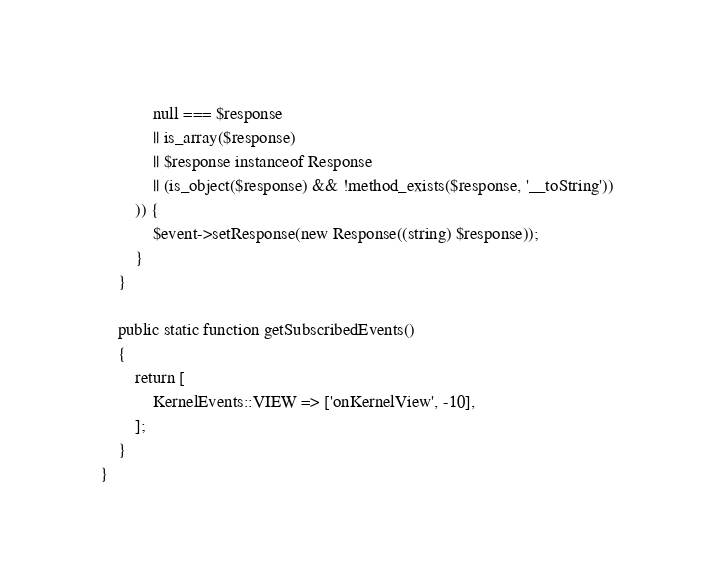Convert code to text. <code><loc_0><loc_0><loc_500><loc_500><_PHP_>            null === $response
            || is_array($response)
            || $response instanceof Response
            || (is_object($response) && !method_exists($response, '__toString'))
        )) {
            $event->setResponse(new Response((string) $response));
        }
    }

    public static function getSubscribedEvents()
    {
        return [
            KernelEvents::VIEW => ['onKernelView', -10],
        ];
    }
}
</code> 